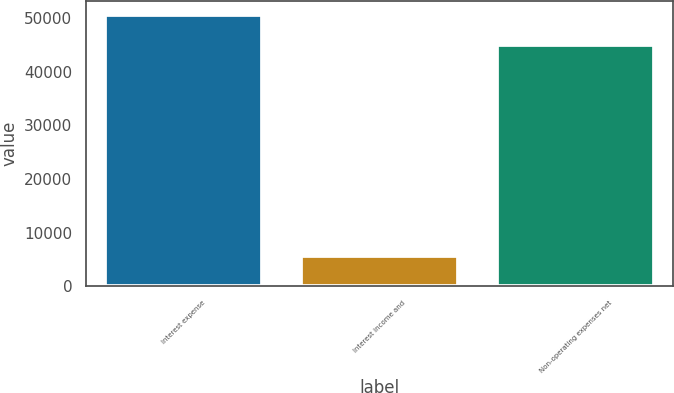Convert chart. <chart><loc_0><loc_0><loc_500><loc_500><bar_chart><fcel>Interest expense<fcel>Interest income and<fcel>Non-operating expenses net<nl><fcel>50629<fcel>5728<fcel>44901<nl></chart> 